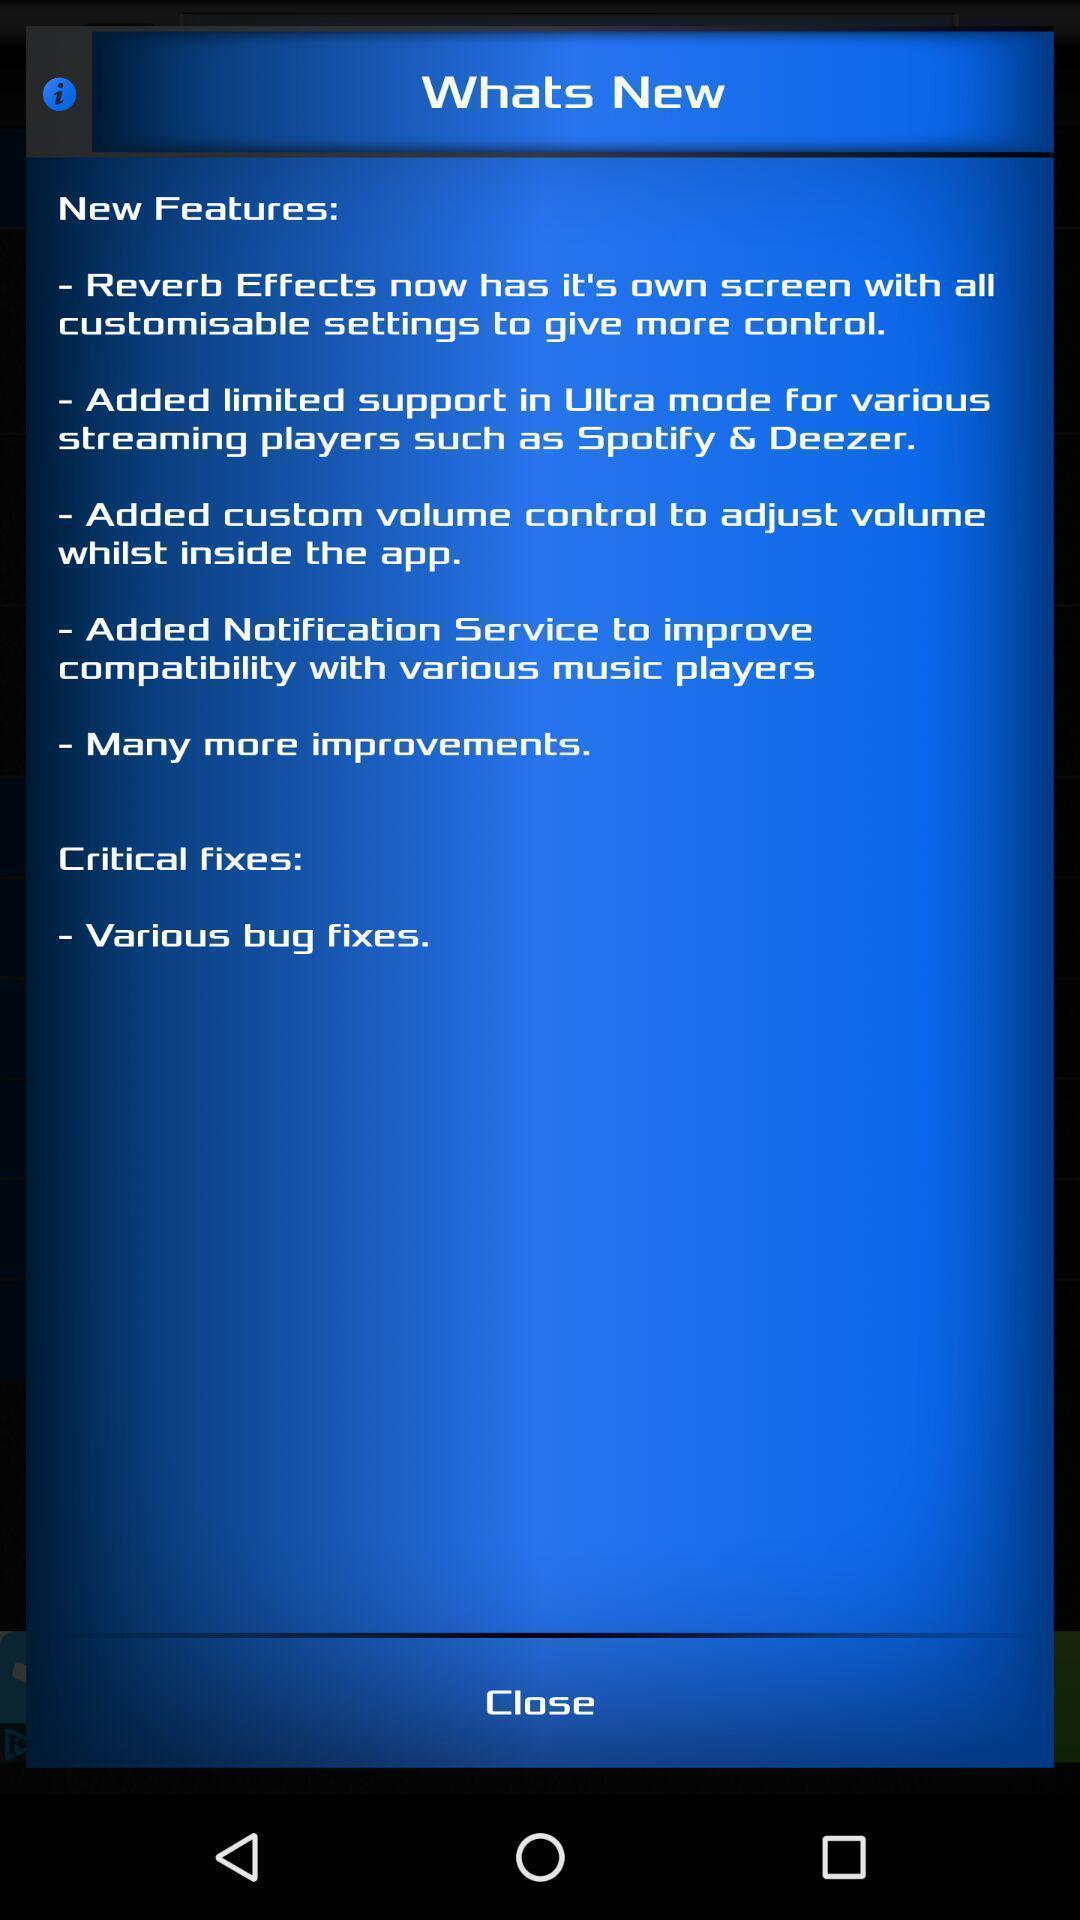Summarize the main components in this picture. Page showing new version of a equalizer app. 